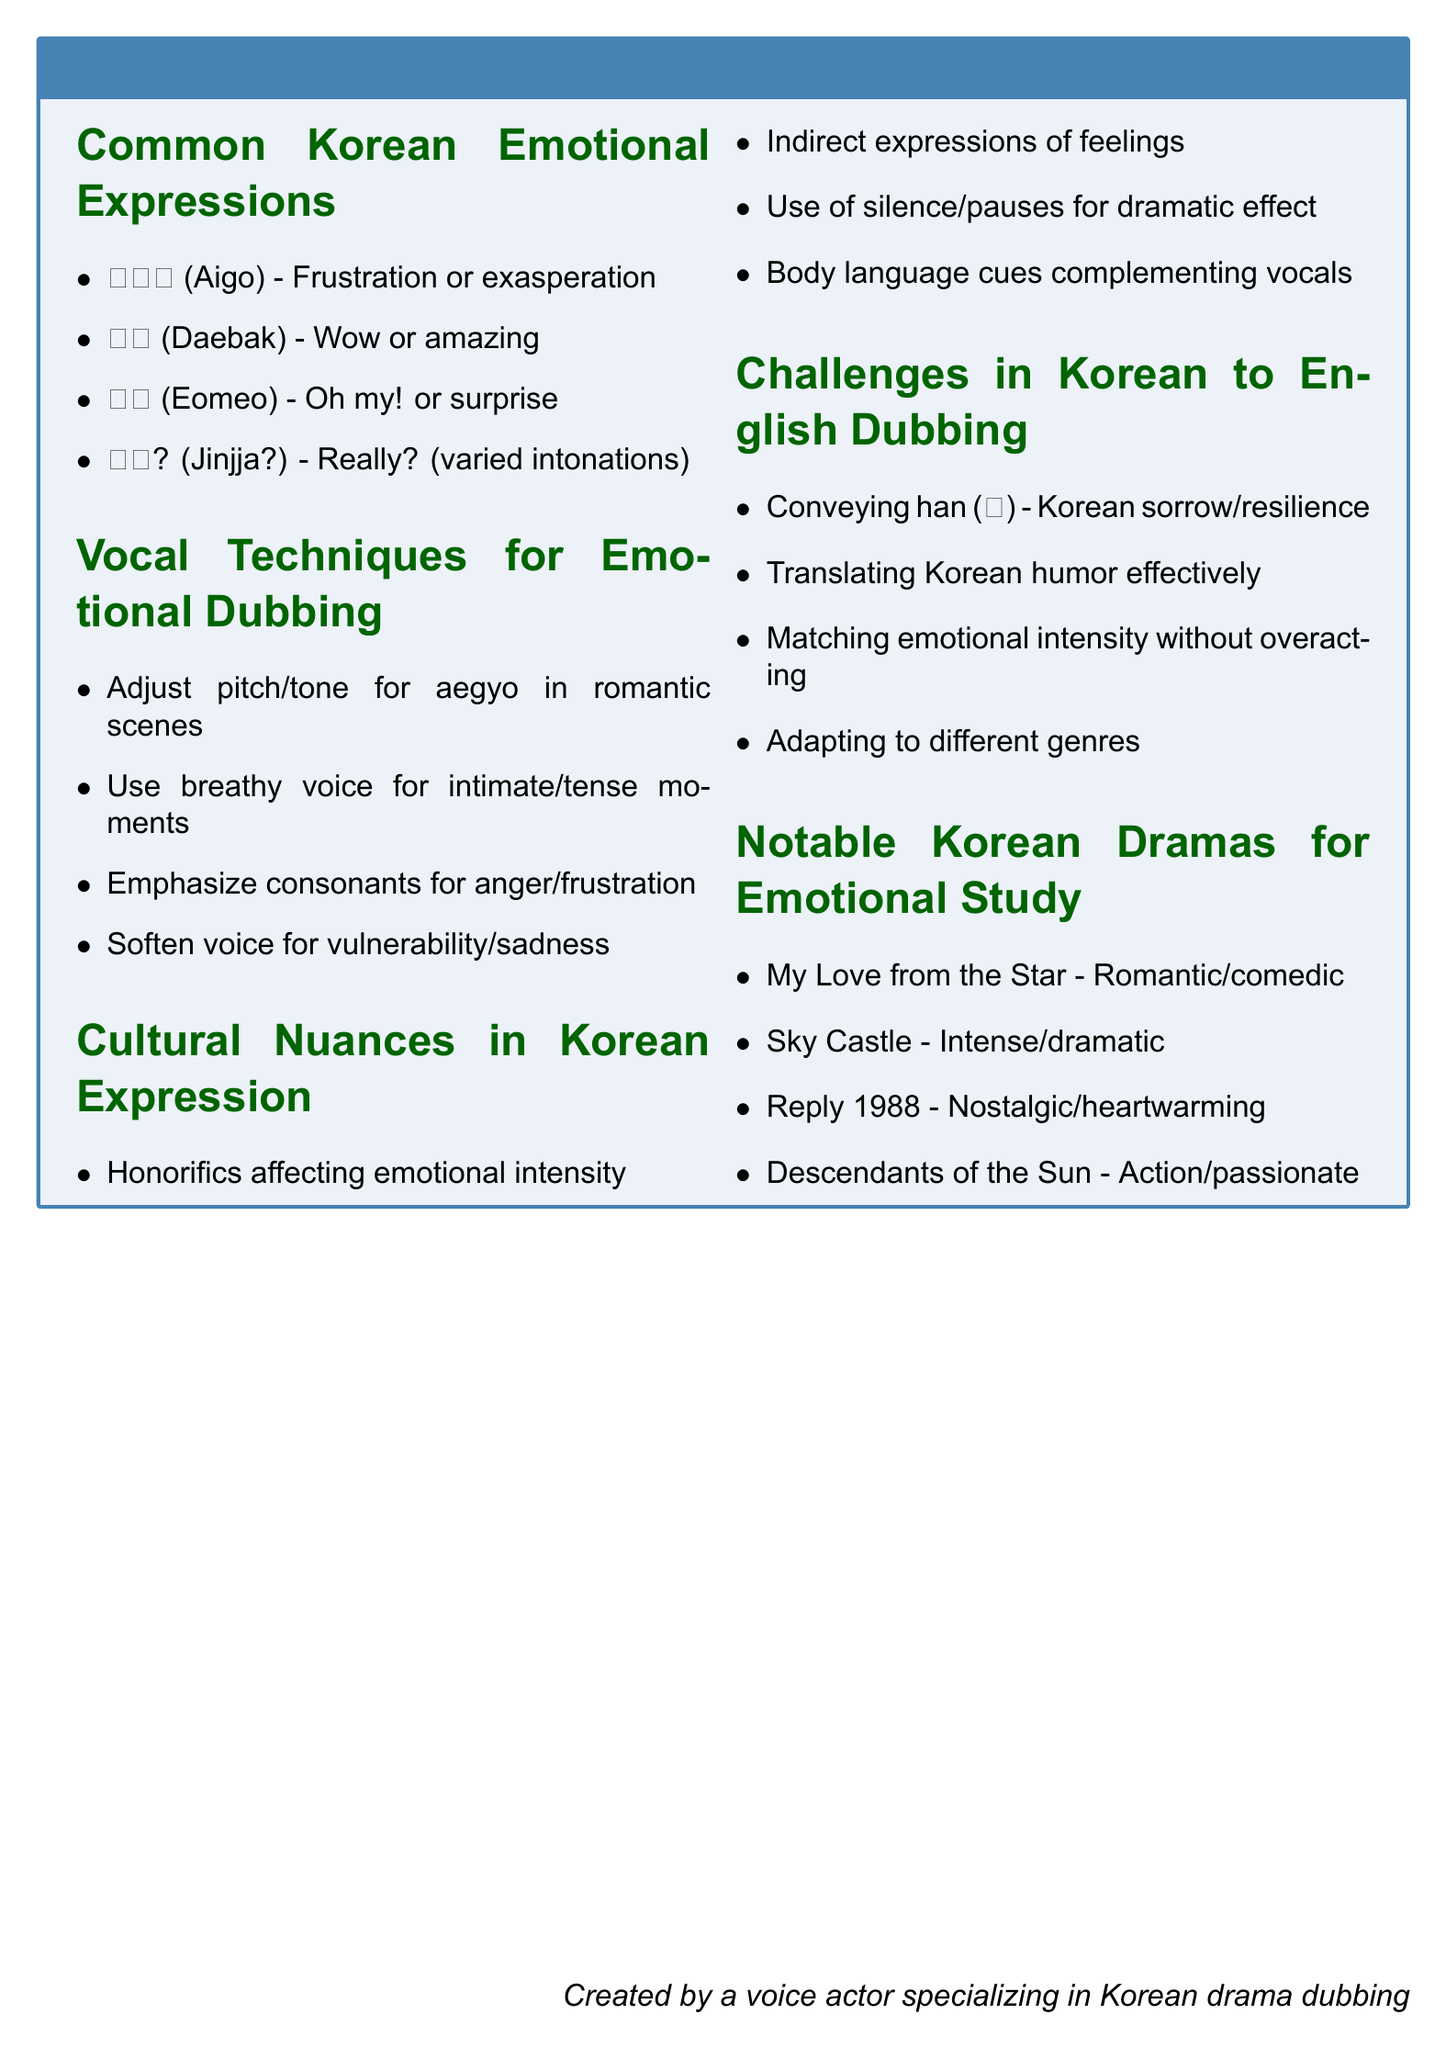What does '아이고' (Aigo) express? '아이고' (Aigo) is an emotional expression indicating frustration or exasperation in Korean.
Answer: Frustration What vocal technique is used for intimate moments? The document mentions using a breathy voice for intimate or tense moments in dubbing.
Answer: Breathy voice Name one show noted for its emotional study in comedy. "My Love from the Star" is listed as a notable drama for romantic and comedic expressions.
Answer: My Love from the Star How does honorifics in Korean dialogue affect emotions? Honorifics are noted for affecting emotional intensity in Korean expressions.
Answer: Emotional intensity What is a challenge in Korean to English emotional dubbing? Conveying 'han' (한) is highlighted as a unique challenge in the document.
Answer: Conveying han What emotional expression means 'Oh my'? The expression '어머' (Eomeo) is interpreted as 'Oh my!' or an expression of surprise.
Answer: Oh my Which drama is recommended for nostalgic tones? "Reply 1988" is mentioned for its nostalgic and heartwarming tones.
Answer: Reply 1988 What should a voice actor adjust for aegyo? The actor should adjust pitch and tone for aegyo in romantic scenes according to the document.
Answer: Pitch and tone 